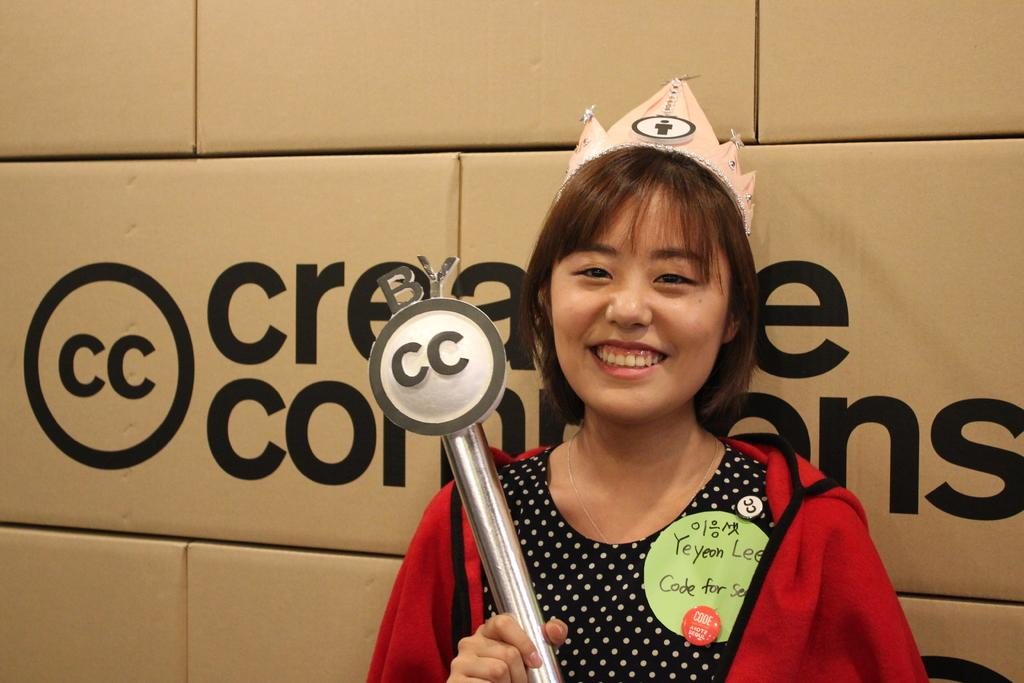What is the woman in the image wearing? The woman is wearing a red jacket. What is the woman doing in the image? The woman is holding an object and smiling. Can you describe the objects behind the woman? There is writing on objects behind the woman. What type of leather does the woman's grandfather use to make his shoes in the image? There is no mention of a grandfather or shoes in the image, so it is not possible to answer that question. 